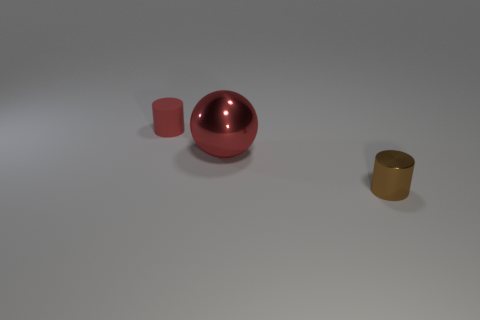Add 3 tiny brown things. How many objects exist? 6 Subtract all spheres. How many objects are left? 2 Add 2 balls. How many balls exist? 3 Subtract 0 blue cubes. How many objects are left? 3 Subtract all small cylinders. Subtract all large red balls. How many objects are left? 0 Add 1 brown things. How many brown things are left? 2 